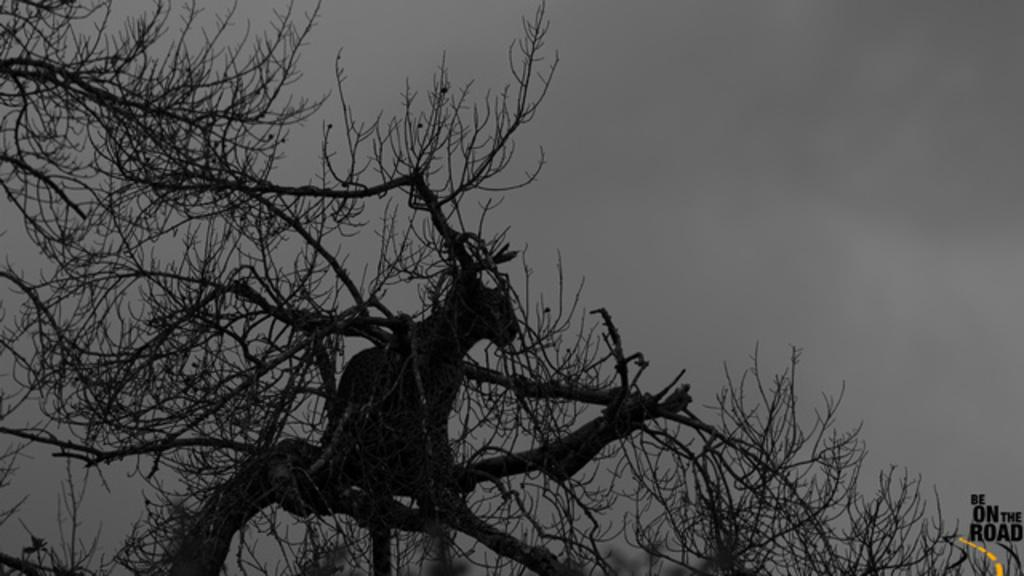What type of vegetation is visible in the image? There are branches of a tree in the image. What can be seen in the background of the image? The sky is visible in the background of the image. What type of joke is being told by the tree in the image? There is no indication in the image that a joke is being told by the tree or any other subject. 